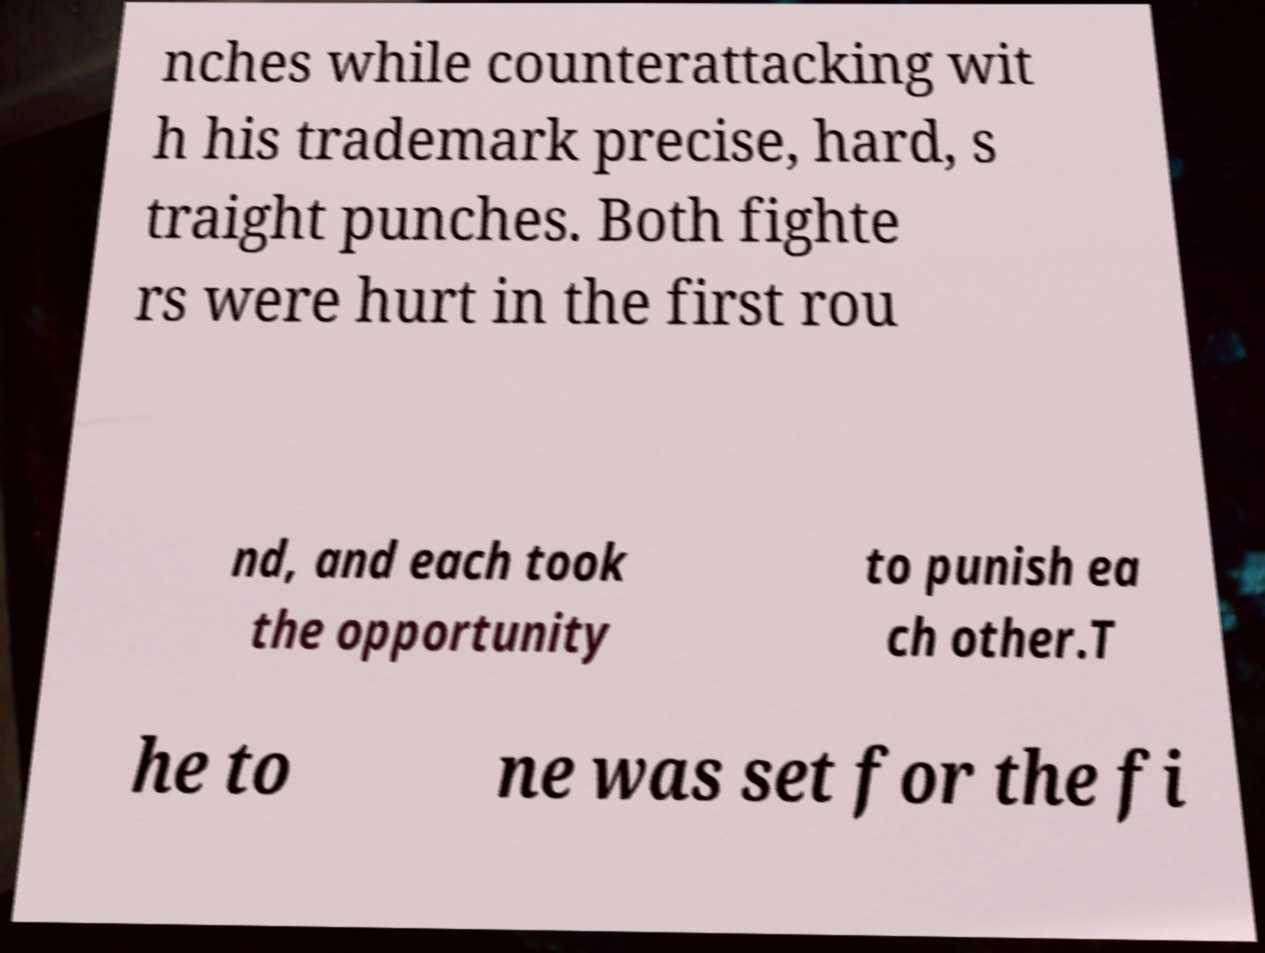Could you assist in decoding the text presented in this image and type it out clearly? nches while counterattacking wit h his trademark precise, hard, s traight punches. Both fighte rs were hurt in the first rou nd, and each took the opportunity to punish ea ch other.T he to ne was set for the fi 